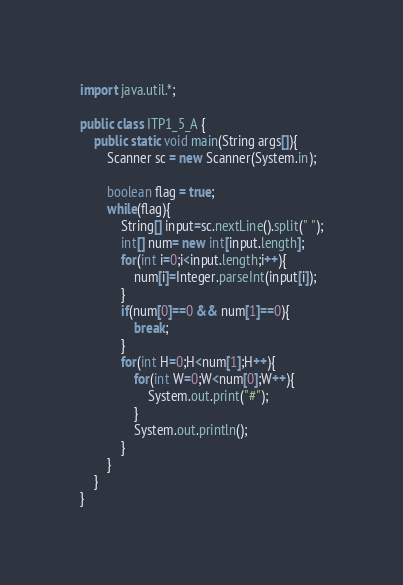Convert code to text. <code><loc_0><loc_0><loc_500><loc_500><_Java_>import java.util.*;

public class ITP1_5_A {
	public static void main(String args[]){
		Scanner sc = new Scanner(System.in);
	
		boolean flag = true;
		while(flag){
			String[] input=sc.nextLine().split(" ");
			int[] num= new int[input.length];
			for(int i=0;i<input.length;i++){
				num[i]=Integer.parseInt(input[i]);
			}
			if(num[0]==0 && num[1]==0){
				break;
			}
			for(int H=0;H<num[1];H++){
				for(int W=0;W<num[0];W++){
					System.out.print("#");
				}
				System.out.println();				
			}
		}
	}
}</code> 